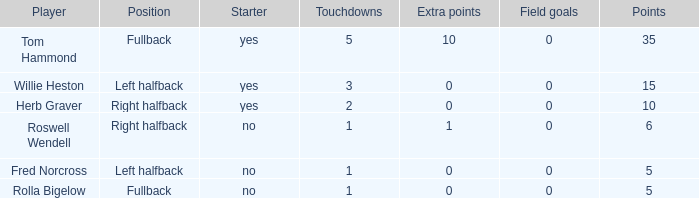What is the lowest number of field goals for a player with 3 touchdowns? 0.0. 